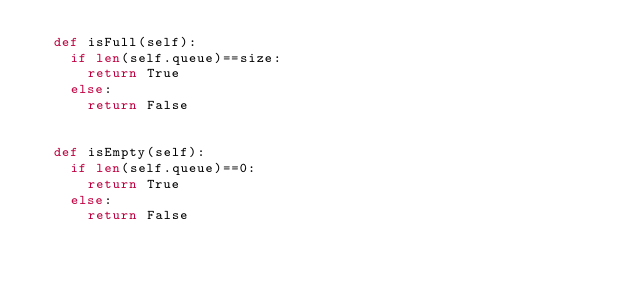Convert code to text. <code><loc_0><loc_0><loc_500><loc_500><_Python_>	def isFull(self):
		if len(self.queue)==size:
			return True
		else:
			return False


	def isEmpty(self):
		if len(self.queue)==0:
			return True
		else:
			return False

</code> 